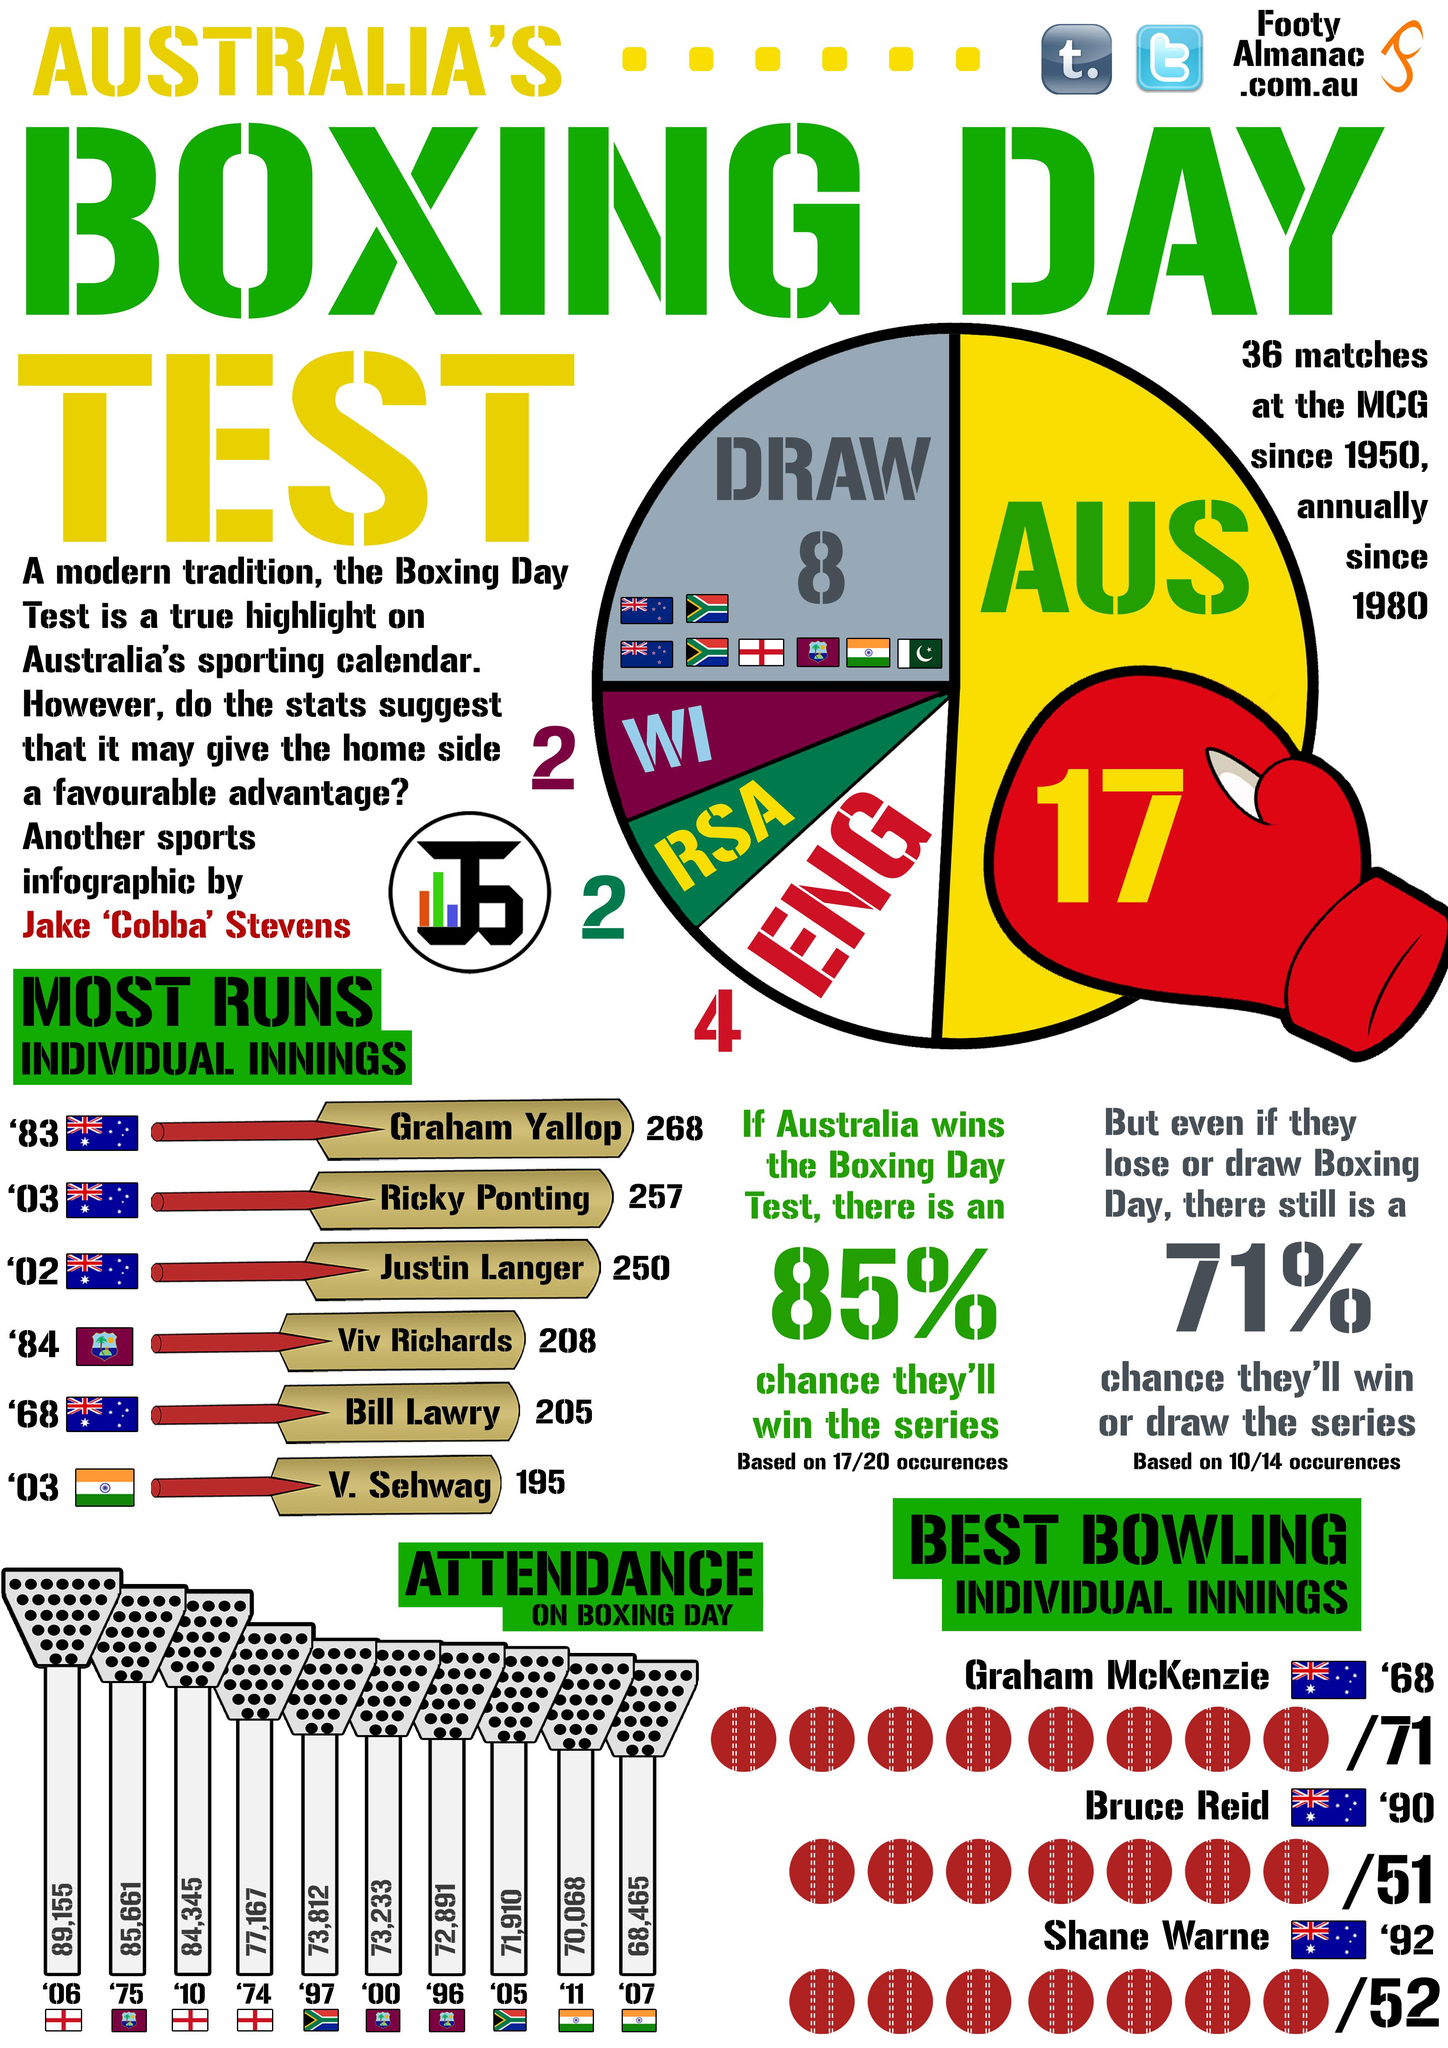Mention a couple of crucial points in this snapshot. Australia has the highest number of wins among the countries of England, Australia, and West Indies. In that game, Sehwag and Langer put up a total of 445 runs, a remarkable feat that will be remembered for years to come. Richards and Lawry combined for a run total of 413! 